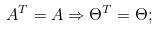<formula> <loc_0><loc_0><loc_500><loc_500>A ^ { T } = A \Rightarrow \Theta ^ { T } = \Theta ;</formula> 